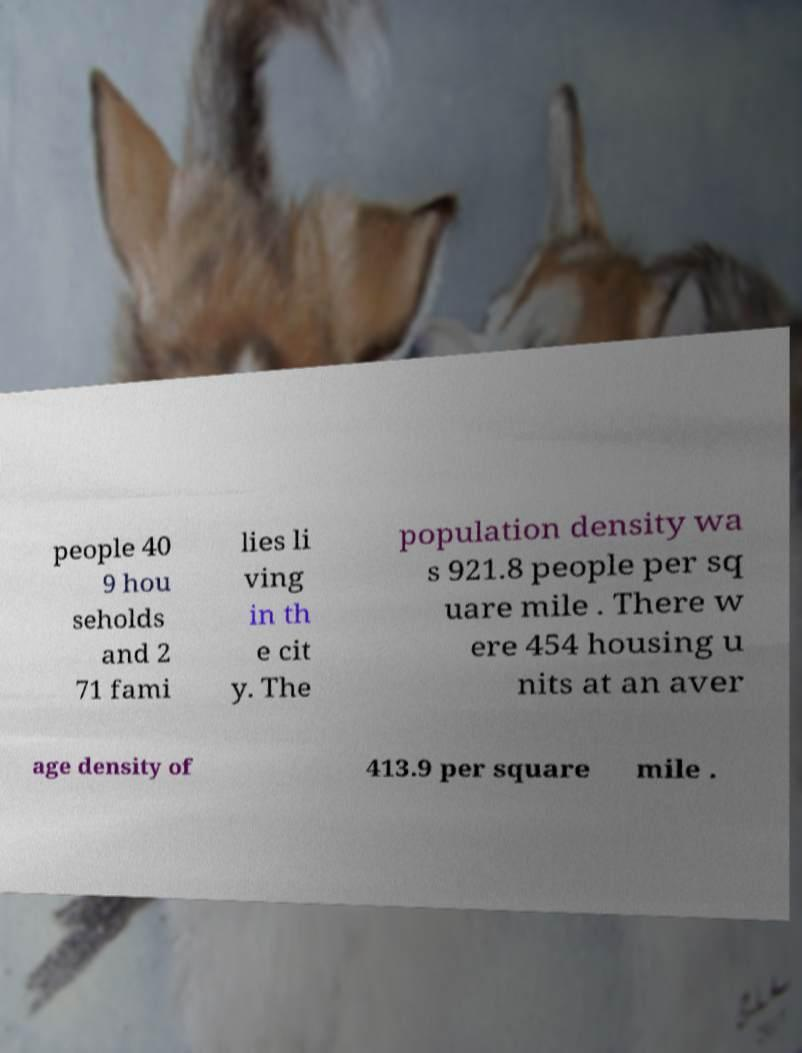Please identify and transcribe the text found in this image. people 40 9 hou seholds and 2 71 fami lies li ving in th e cit y. The population density wa s 921.8 people per sq uare mile . There w ere 454 housing u nits at an aver age density of 413.9 per square mile . 